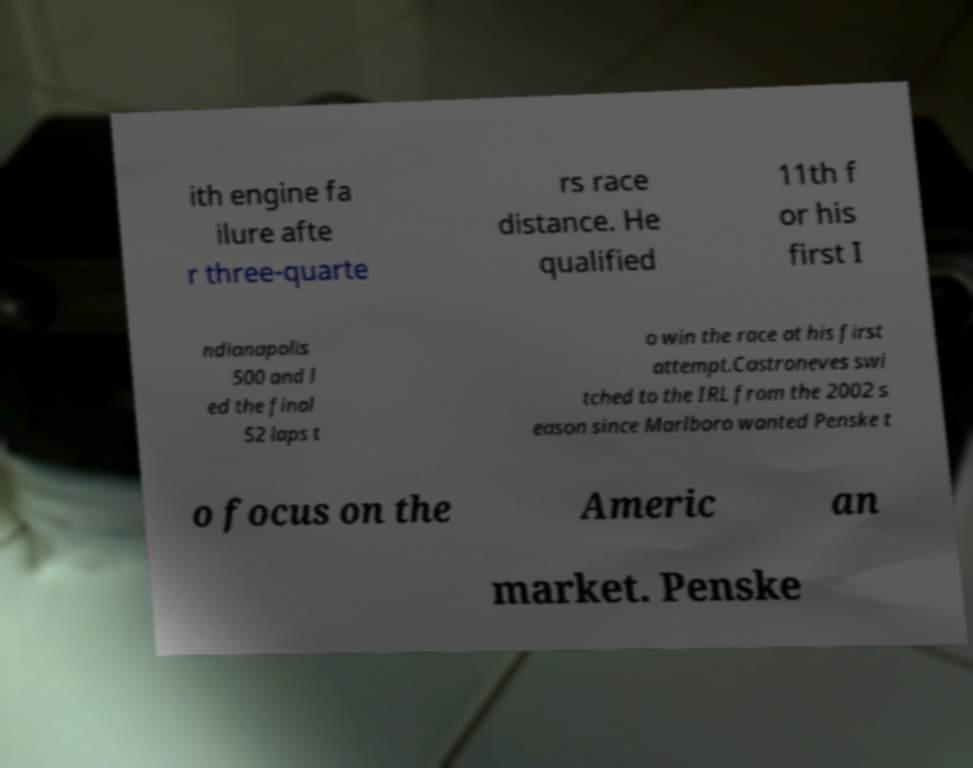Could you extract and type out the text from this image? ith engine fa ilure afte r three-quarte rs race distance. He qualified 11th f or his first I ndianapolis 500 and l ed the final 52 laps t o win the race at his first attempt.Castroneves swi tched to the IRL from the 2002 s eason since Marlboro wanted Penske t o focus on the Americ an market. Penske 